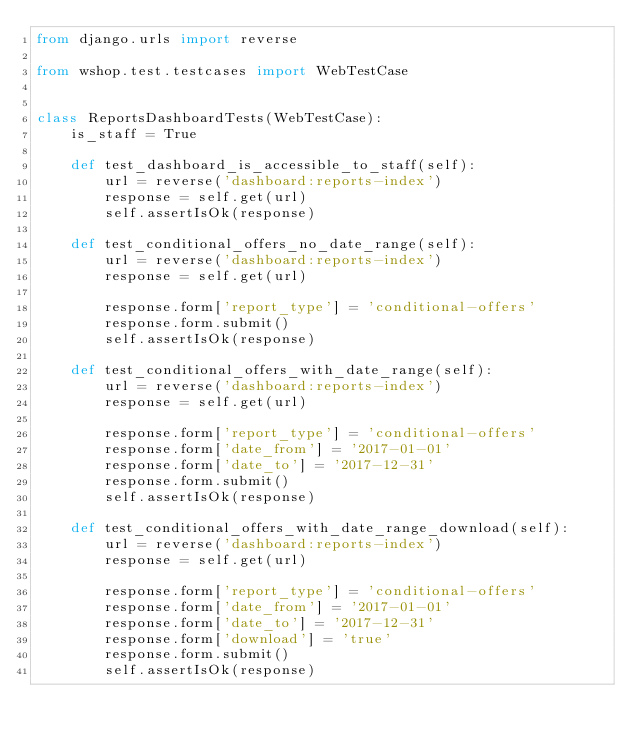Convert code to text. <code><loc_0><loc_0><loc_500><loc_500><_Python_>from django.urls import reverse

from wshop.test.testcases import WebTestCase


class ReportsDashboardTests(WebTestCase):
    is_staff = True

    def test_dashboard_is_accessible_to_staff(self):
        url = reverse('dashboard:reports-index')
        response = self.get(url)
        self.assertIsOk(response)

    def test_conditional_offers_no_date_range(self):
        url = reverse('dashboard:reports-index')
        response = self.get(url)

        response.form['report_type'] = 'conditional-offers'
        response.form.submit()
        self.assertIsOk(response)

    def test_conditional_offers_with_date_range(self):
        url = reverse('dashboard:reports-index')
        response = self.get(url)

        response.form['report_type'] = 'conditional-offers'
        response.form['date_from'] = '2017-01-01'
        response.form['date_to'] = '2017-12-31'
        response.form.submit()
        self.assertIsOk(response)

    def test_conditional_offers_with_date_range_download(self):
        url = reverse('dashboard:reports-index')
        response = self.get(url)

        response.form['report_type'] = 'conditional-offers'
        response.form['date_from'] = '2017-01-01'
        response.form['date_to'] = '2017-12-31'
        response.form['download'] = 'true'
        response.form.submit()
        self.assertIsOk(response)
</code> 